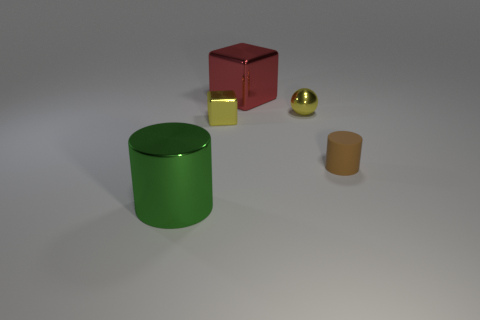There is a large shiny object behind the large green object; is its color the same as the cylinder that is to the right of the big green metallic object?
Keep it short and to the point. No. What is the size of the brown rubber object that is the same shape as the big green shiny object?
Keep it short and to the point. Small. Does the tiny thing that is left of the shiny sphere have the same material as the large red object that is left of the tiny cylinder?
Make the answer very short. Yes. What number of metal things are big things or tiny red objects?
Keep it short and to the point. 2. There is a cube behind the small yellow shiny thing that is left of the big metallic thing that is behind the big cylinder; what is it made of?
Offer a very short reply. Metal. There is a tiny yellow thing that is behind the tiny yellow block; does it have the same shape as the large object in front of the brown cylinder?
Provide a succinct answer. No. What is the color of the large shiny thing behind the cylinder to the right of the red metallic cube?
Offer a terse response. Red. What number of spheres are large gray shiny objects or yellow objects?
Your response must be concise. 1. How many large green metal cylinders are behind the big object right of the thing in front of the small brown cylinder?
Provide a short and direct response. 0. What size is the object that is the same color as the small block?
Your answer should be very brief. Small. 